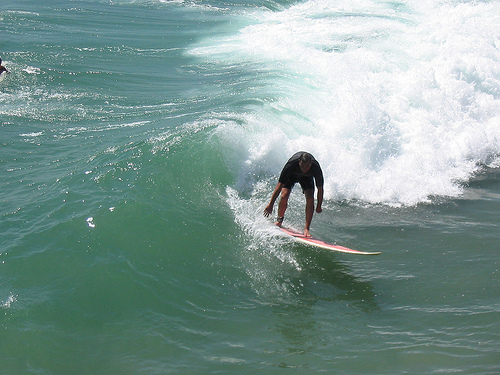Please provide the bounding box coordinate of the region this sentence describes: the arm of a surfer. The coordinates for the surfer's arm are [0.63, 0.46, 0.65, 0.56]. The arm is extended towards the wave for balance. 